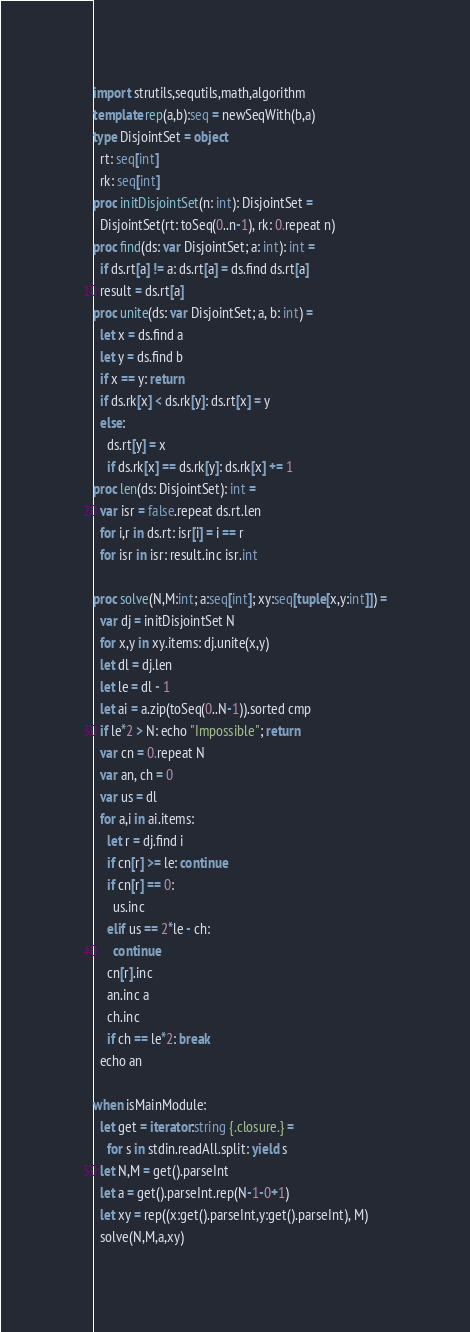Convert code to text. <code><loc_0><loc_0><loc_500><loc_500><_Nim_>import strutils,sequtils,math,algorithm
template rep(a,b):seq = newSeqWith(b,a)
type DisjointSet = object
  rt: seq[int]
  rk: seq[int]
proc initDisjointSet(n: int): DisjointSet =
  DisjointSet(rt: toSeq(0..n-1), rk: 0.repeat n)
proc find(ds: var DisjointSet; a: int): int =
  if ds.rt[a] != a: ds.rt[a] = ds.find ds.rt[a]
  result = ds.rt[a]
proc unite(ds: var DisjointSet; a, b: int) =
  let x = ds.find a
  let y = ds.find b
  if x == y: return
  if ds.rk[x] < ds.rk[y]: ds.rt[x] = y
  else:
    ds.rt[y] = x
    if ds.rk[x] == ds.rk[y]: ds.rk[x] += 1
proc len(ds: DisjointSet): int =
  var isr = false.repeat ds.rt.len
  for i,r in ds.rt: isr[i] = i == r
  for isr in isr: result.inc isr.int

proc solve(N,M:int; a:seq[int]; xy:seq[tuple[x,y:int]]) =
  var dj = initDisjointSet N
  for x,y in xy.items: dj.unite(x,y)
  let dl = dj.len
  let le = dl - 1
  let ai = a.zip(toSeq(0..N-1)).sorted cmp
  if le*2 > N: echo "Impossible"; return
  var cn = 0.repeat N
  var an, ch = 0
  var us = dl
  for a,i in ai.items:
    let r = dj.find i
    if cn[r] >= le: continue
    if cn[r] == 0:
      us.inc
    elif us == 2*le - ch:
      continue
    cn[r].inc
    an.inc a
    ch.inc
    if ch == le*2: break
  echo an
 
when isMainModule:
  let get = iterator:string {.closure.} = 
    for s in stdin.readAll.split: yield s
  let N,M = get().parseInt
  let a = get().parseInt.rep(N-1-0+1)
  let xy = rep((x:get().parseInt,y:get().parseInt), M)
  solve(N,M,a,xy)

</code> 